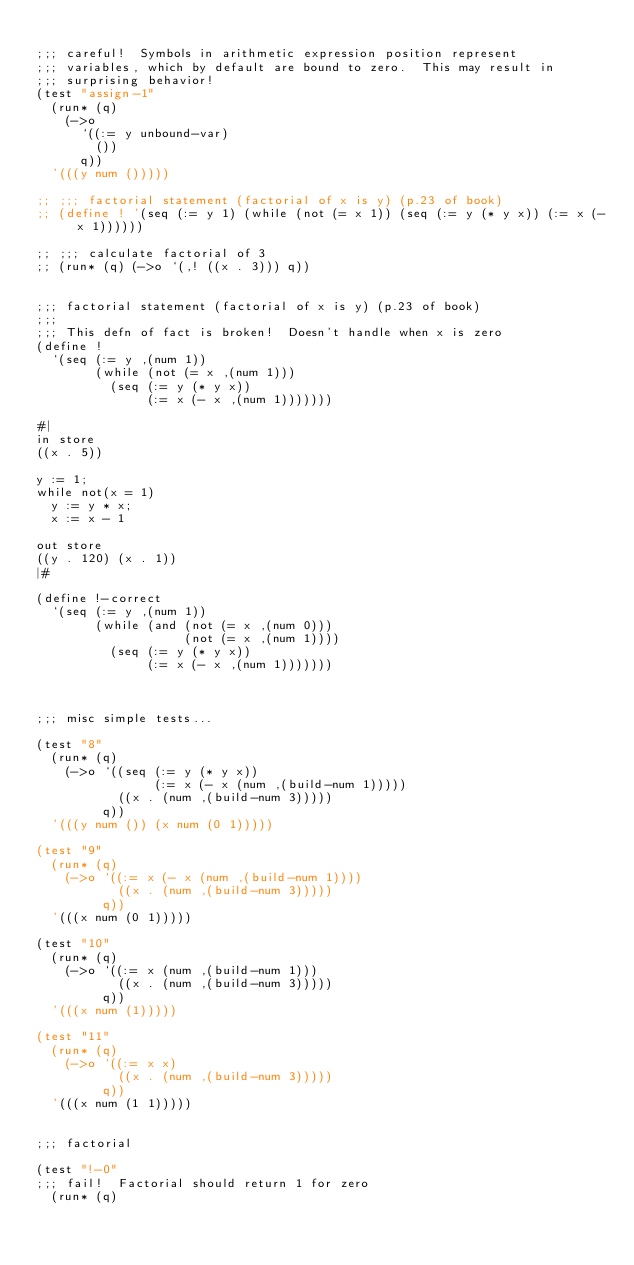<code> <loc_0><loc_0><loc_500><loc_500><_Scheme_>
;;; careful!  Symbols in arithmetic expression position represent
;;; variables, which by default are bound to zero.  This may result in
;;; surprising behavior!
(test "assign-1"
  (run* (q)
    (->o
      `((:= y unbound-var)
        ())
      q))
  '(((y num ()))))

;; ;;; factorial statement (factorial of x is y) (p.23 of book)
;; (define ! '(seq (:= y 1) (while (not (= x 1)) (seq (:= y (* y x)) (:= x (- x 1))))))

;; ;;; calculate factorial of 3
;; (run* (q) (->o `(,! ((x . 3))) q))


;;; factorial statement (factorial of x is y) (p.23 of book)
;;;
;;; This defn of fact is broken!  Doesn't handle when x is zero
(define !
  `(seq (:= y ,(num 1))
        (while (not (= x ,(num 1)))
          (seq (:= y (* y x))
               (:= x (- x ,(num 1)))))))

#|
in store
((x . 5))

y := 1;
while not(x = 1)
  y := y * x;
  x := x - 1

out store
((y . 120) (x . 1))
|#

(define !-correct
  `(seq (:= y ,(num 1))
        (while (and (not (= x ,(num 0)))
                    (not (= x ,(num 1))))
          (seq (:= y (* y x))
               (:= x (- x ,(num 1)))))))



;;; misc simple tests...

(test "8"
  (run* (q)
    (->o `((seq (:= y (* y x))
                (:= x (- x (num ,(build-num 1)))))
           ((x . (num ,(build-num 3)))))
         q))
  '(((y num ()) (x num (0 1)))))

(test "9"
  (run* (q)
    (->o `((:= x (- x (num ,(build-num 1))))
           ((x . (num ,(build-num 3)))))
         q))
  '(((x num (0 1)))))

(test "10"
  (run* (q)
    (->o `((:= x (num ,(build-num 1)))
           ((x . (num ,(build-num 3)))))
         q))
  '(((x num (1)))))

(test "11"
  (run* (q)
    (->o `((:= x x)
           ((x . (num ,(build-num 3)))))
         q))
  '(((x num (1 1)))))


;;; factorial

(test "!-0"
;;; fail!  Factorial should return 1 for zero 
  (run* (q)</code> 